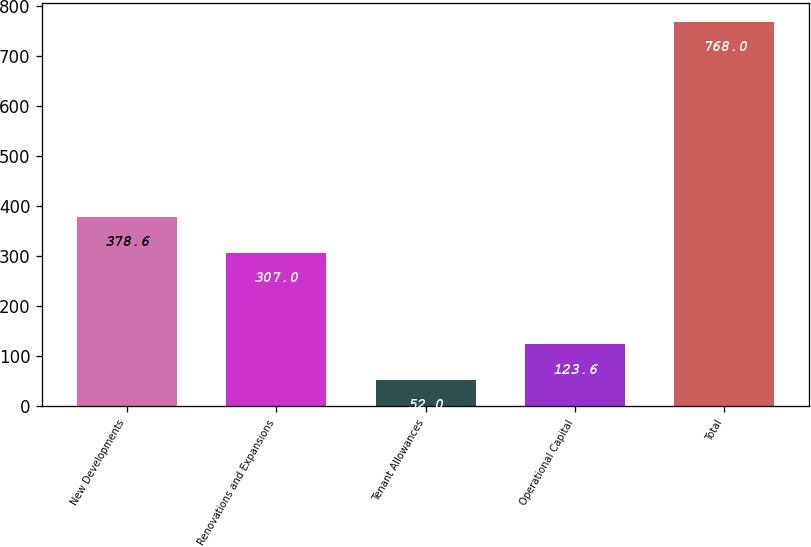<chart> <loc_0><loc_0><loc_500><loc_500><bar_chart><fcel>New Developments<fcel>Renovations and Expansions<fcel>Tenant Allowances<fcel>Operational Capital<fcel>Total<nl><fcel>378.6<fcel>307<fcel>52<fcel>123.6<fcel>768<nl></chart> 